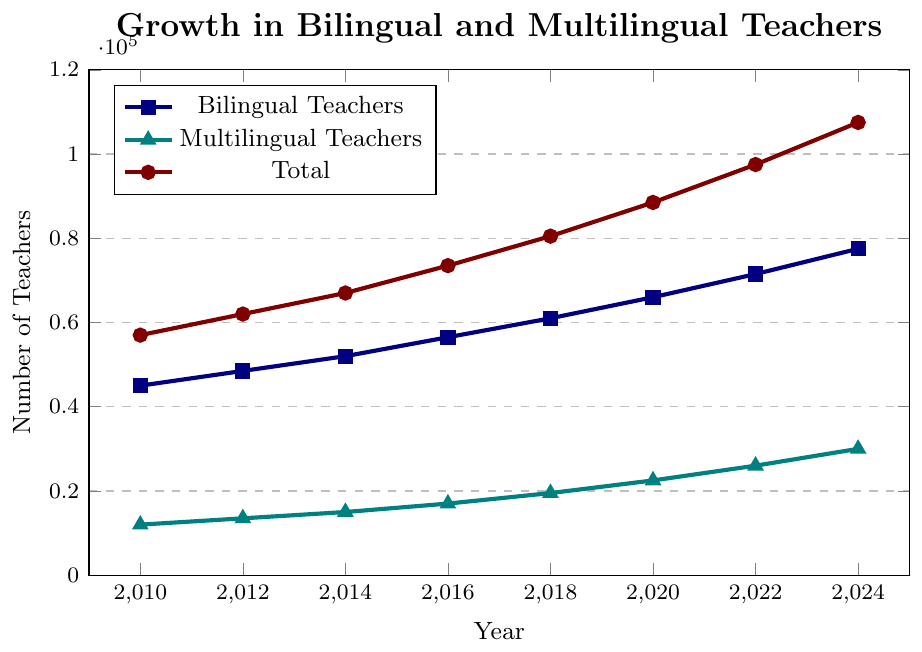What is the total number of teachers (bilingual and multilingual) employed in 2018? From the figure, the total number of teachers is marked with a maroon-colored line. Find the value on the y-axis for the year 2018, which is marked above 80,000.
Answer: 80,500 Which group of teachers had the highest increase in number from 2010 to 2024? Compare the increase for each group from 2010 to 2024 using the y-axis values: Bilingual Teachers: 77,500 - 45,000 = 32,500; Multilingual Teachers: 30,000 - 12,000 = 18,000; Total: 107,500 - 57,000 = 50,500. The total group had the highest increase.
Answer: Total By how much did the number of bilingual teachers grow from 2016 to 2020? Find the values for the number of bilingual teachers in 2016 and 2020 from the navy-colored line, then subtract the 2016 value from the 2020 value: 66,000 - 56,500 = 9,500.
Answer: 9,500 Which year saw the number of multilingual teachers reaching 22,500? Locate the teal-colored line depicting multilingual teachers and identify the year when the value is 22,500, which is in 2020.
Answer: 2020 What is the average number of multilingual teachers over the years? Sum the number of multilingual teachers over all years: (12,000 + 13,500 + 15,000 + 17,000 + 19,500 + 22,500 + 26,000 + 30,000) = 155,500. Divide by the number of years (8): 155,500 / 8 = 19,437.5.
Answer: 19,437.5 How does the growth trend of bilingual teachers compare to multilingual teachers between 2010 and 2024? Observe the slopes of the navy and teal-colored lines; the navy line (bilingual teachers) grows more steeply than the teal line (multilingual teachers), indicating faster growth in the number of bilingual teachers.
Answer: Bilingual teachers grew faster Are there any years when the increase in the number of multilingual teachers between consecutive years was higher than that of bilingual teachers? Calculate the increase for each consecutive period for both groups and compare:
2010-2012: Bilingual: 3,500, Multilingual: 1,500
2012-2014: Bilingual: 3,500, Multilingual: 1,500
2014-2016: Bilingual: 4,500, Multilingual: 2,000
2016-2018: Bilingual: 4,500, Multilingual: 2,500
2018-2020: Bilingual: 5,000, Multilingual: 3,000
2020-2022: Bilingual: 5,500, Multilingual: 3,500
2022-2024: Bilingual: 6,000, Multilingual: 4,000. Multilingual teachers had higher growth than bilingual teachers in the periods 2016-2018 and 2020-2024.
Answer: Yes, in 2016-2018 and 2020-2024 What percentage of the total number of teachers in 2024 are multilingual teachers? First find the number of multilingual teachers and the total number of teachers in 2024: Total: 107,500, Multilingual: 30,000. Calculate the percentage: (30,000 / 107,500) * 100 ≈ 27.91%.
Answer: 27.91% By how much did the total number of teachers increase from 2010 to 2022? Find the total number of teachers in 2010 and 2022 from the maroon line and subtract: 97,500 - 57,000 = 40,500.
Answer: 40,500 